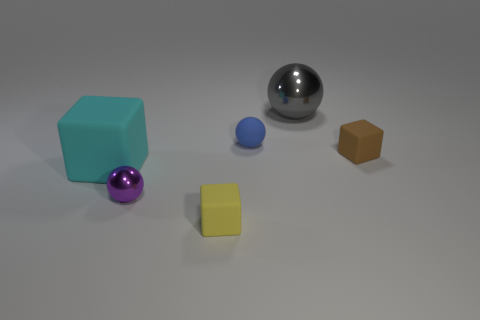Add 4 big gray objects. How many objects exist? 10 Subtract 0 brown balls. How many objects are left? 6 Subtract all large red rubber spheres. Subtract all small purple shiny things. How many objects are left? 5 Add 5 gray metal objects. How many gray metal objects are left? 6 Add 1 large cubes. How many large cubes exist? 2 